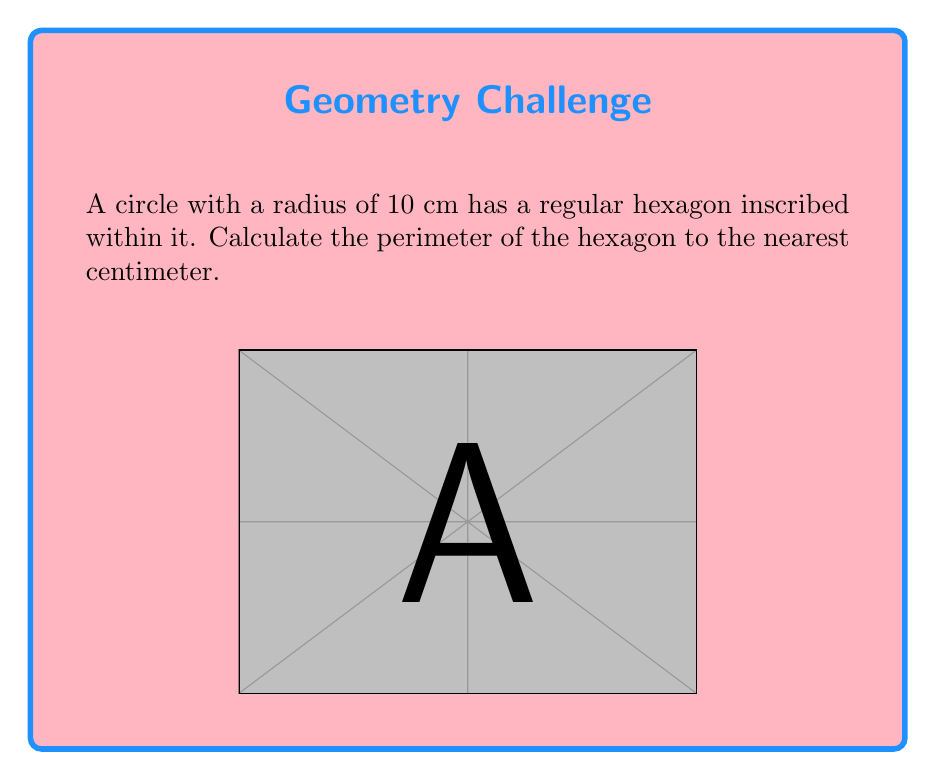Could you help me with this problem? Let's approach this step-by-step:

1) In a regular hexagon inscribed in a circle, each side of the hexagon is equal to the radius of the circle. This is because the hexagon divides the circle into six equal central angles, each measuring 60°.

2) We can prove this mathematically:
   - The central angle for each side is $\frac{360°}{6} = 60°$
   - In a 30-60-90 triangle, the ratio of sides is 1 : $\sqrt{3}$ : 2
   - The side of the hexagon forms the longest side of this triangle, which is equal to the radius

3) Given:
   - Radius of the circle, $r = 10$ cm
   - Number of sides in a hexagon, $n = 6$

4) Since each side of the hexagon is equal to the radius:
   Side length, $s = r = 10$ cm

5) The perimeter of a regular polygon is given by the formula:
   $$P = ns$$
   where $n$ is the number of sides and $s$ is the length of each side

6) Substituting our values:
   $$P = 6 \times 10 = 60\text{ cm}$$

7) The question asks for the answer to the nearest centimeter, but our result is already a whole number, so no rounding is necessary.
Answer: 60 cm 